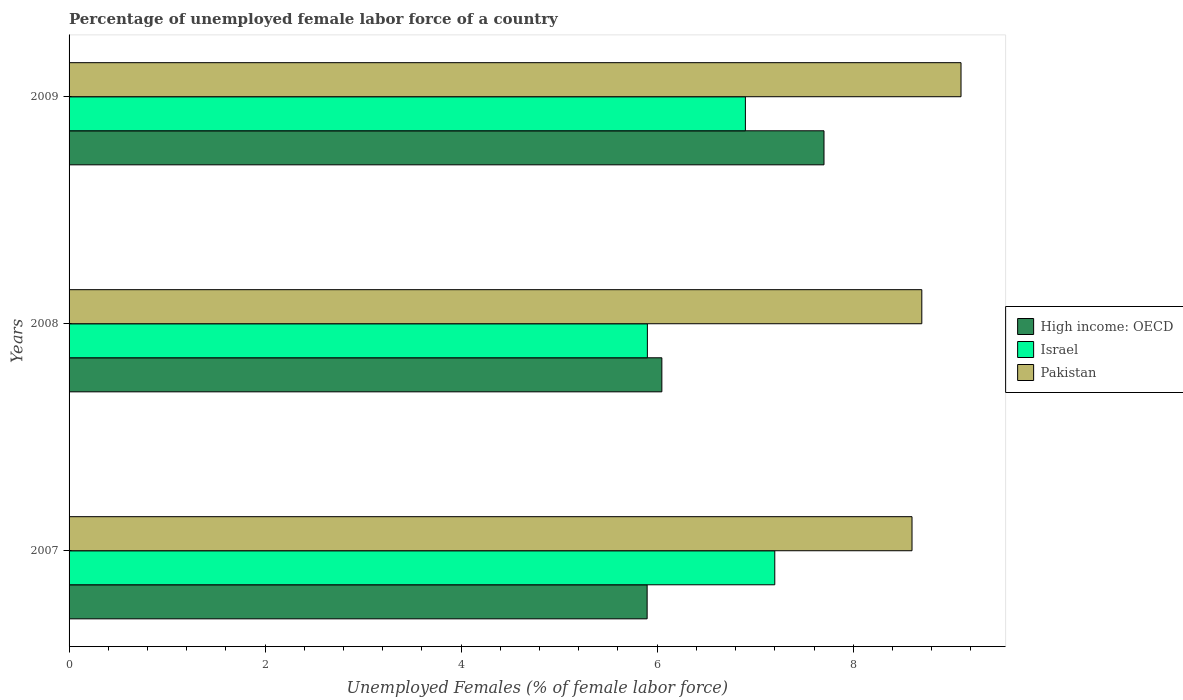How many different coloured bars are there?
Provide a short and direct response. 3. In how many cases, is the number of bars for a given year not equal to the number of legend labels?
Give a very brief answer. 0. What is the percentage of unemployed female labor force in High income: OECD in 2009?
Offer a terse response. 7.7. Across all years, what is the maximum percentage of unemployed female labor force in Pakistan?
Make the answer very short. 9.1. Across all years, what is the minimum percentage of unemployed female labor force in High income: OECD?
Provide a succinct answer. 5.9. In which year was the percentage of unemployed female labor force in Pakistan minimum?
Your answer should be very brief. 2007. What is the total percentage of unemployed female labor force in High income: OECD in the graph?
Your answer should be very brief. 19.65. What is the difference between the percentage of unemployed female labor force in High income: OECD in 2008 and that in 2009?
Provide a succinct answer. -1.65. What is the difference between the percentage of unemployed female labor force in Israel in 2008 and the percentage of unemployed female labor force in Pakistan in 2007?
Provide a short and direct response. -2.7. What is the average percentage of unemployed female labor force in High income: OECD per year?
Offer a terse response. 6.55. In the year 2009, what is the difference between the percentage of unemployed female labor force in Israel and percentage of unemployed female labor force in High income: OECD?
Make the answer very short. -0.8. What is the ratio of the percentage of unemployed female labor force in Pakistan in 2008 to that in 2009?
Keep it short and to the point. 0.96. Is the difference between the percentage of unemployed female labor force in Israel in 2007 and 2008 greater than the difference between the percentage of unemployed female labor force in High income: OECD in 2007 and 2008?
Give a very brief answer. Yes. What is the difference between the highest and the second highest percentage of unemployed female labor force in Israel?
Provide a short and direct response. 0.3. What is the difference between the highest and the lowest percentage of unemployed female labor force in High income: OECD?
Your response must be concise. 1.8. In how many years, is the percentage of unemployed female labor force in High income: OECD greater than the average percentage of unemployed female labor force in High income: OECD taken over all years?
Provide a short and direct response. 1. Is it the case that in every year, the sum of the percentage of unemployed female labor force in Israel and percentage of unemployed female labor force in High income: OECD is greater than the percentage of unemployed female labor force in Pakistan?
Provide a succinct answer. Yes. Are all the bars in the graph horizontal?
Your response must be concise. Yes. How many years are there in the graph?
Provide a short and direct response. 3. What is the difference between two consecutive major ticks on the X-axis?
Offer a terse response. 2. How are the legend labels stacked?
Ensure brevity in your answer.  Vertical. What is the title of the graph?
Ensure brevity in your answer.  Percentage of unemployed female labor force of a country. Does "St. Vincent and the Grenadines" appear as one of the legend labels in the graph?
Offer a terse response. No. What is the label or title of the X-axis?
Make the answer very short. Unemployed Females (% of female labor force). What is the Unemployed Females (% of female labor force) in High income: OECD in 2007?
Your answer should be compact. 5.9. What is the Unemployed Females (% of female labor force) in Israel in 2007?
Make the answer very short. 7.2. What is the Unemployed Females (% of female labor force) of Pakistan in 2007?
Offer a very short reply. 8.6. What is the Unemployed Females (% of female labor force) of High income: OECD in 2008?
Your response must be concise. 6.05. What is the Unemployed Females (% of female labor force) in Israel in 2008?
Give a very brief answer. 5.9. What is the Unemployed Females (% of female labor force) in Pakistan in 2008?
Your answer should be very brief. 8.7. What is the Unemployed Females (% of female labor force) in High income: OECD in 2009?
Your response must be concise. 7.7. What is the Unemployed Females (% of female labor force) of Israel in 2009?
Provide a short and direct response. 6.9. What is the Unemployed Females (% of female labor force) in Pakistan in 2009?
Make the answer very short. 9.1. Across all years, what is the maximum Unemployed Females (% of female labor force) of High income: OECD?
Offer a terse response. 7.7. Across all years, what is the maximum Unemployed Females (% of female labor force) of Israel?
Provide a short and direct response. 7.2. Across all years, what is the maximum Unemployed Females (% of female labor force) in Pakistan?
Give a very brief answer. 9.1. Across all years, what is the minimum Unemployed Females (% of female labor force) of High income: OECD?
Ensure brevity in your answer.  5.9. Across all years, what is the minimum Unemployed Females (% of female labor force) of Israel?
Your answer should be very brief. 5.9. Across all years, what is the minimum Unemployed Females (% of female labor force) in Pakistan?
Your answer should be very brief. 8.6. What is the total Unemployed Females (% of female labor force) in High income: OECD in the graph?
Offer a terse response. 19.65. What is the total Unemployed Females (% of female labor force) of Israel in the graph?
Keep it short and to the point. 20. What is the total Unemployed Females (% of female labor force) in Pakistan in the graph?
Your response must be concise. 26.4. What is the difference between the Unemployed Females (% of female labor force) in High income: OECD in 2007 and that in 2008?
Offer a terse response. -0.15. What is the difference between the Unemployed Females (% of female labor force) of Israel in 2007 and that in 2008?
Your answer should be compact. 1.3. What is the difference between the Unemployed Females (% of female labor force) of High income: OECD in 2007 and that in 2009?
Offer a terse response. -1.8. What is the difference between the Unemployed Females (% of female labor force) of Israel in 2007 and that in 2009?
Your answer should be very brief. 0.3. What is the difference between the Unemployed Females (% of female labor force) in Pakistan in 2007 and that in 2009?
Give a very brief answer. -0.5. What is the difference between the Unemployed Females (% of female labor force) in High income: OECD in 2008 and that in 2009?
Your answer should be compact. -1.65. What is the difference between the Unemployed Females (% of female labor force) of Israel in 2008 and that in 2009?
Offer a terse response. -1. What is the difference between the Unemployed Females (% of female labor force) in Pakistan in 2008 and that in 2009?
Provide a short and direct response. -0.4. What is the difference between the Unemployed Females (% of female labor force) in High income: OECD in 2007 and the Unemployed Females (% of female labor force) in Israel in 2008?
Ensure brevity in your answer.  -0. What is the difference between the Unemployed Females (% of female labor force) in High income: OECD in 2007 and the Unemployed Females (% of female labor force) in Pakistan in 2008?
Offer a terse response. -2.8. What is the difference between the Unemployed Females (% of female labor force) in Israel in 2007 and the Unemployed Females (% of female labor force) in Pakistan in 2008?
Offer a very short reply. -1.5. What is the difference between the Unemployed Females (% of female labor force) of High income: OECD in 2007 and the Unemployed Females (% of female labor force) of Israel in 2009?
Keep it short and to the point. -1. What is the difference between the Unemployed Females (% of female labor force) in High income: OECD in 2007 and the Unemployed Females (% of female labor force) in Pakistan in 2009?
Your answer should be very brief. -3.2. What is the difference between the Unemployed Females (% of female labor force) of High income: OECD in 2008 and the Unemployed Females (% of female labor force) of Israel in 2009?
Provide a succinct answer. -0.85. What is the difference between the Unemployed Females (% of female labor force) in High income: OECD in 2008 and the Unemployed Females (% of female labor force) in Pakistan in 2009?
Offer a very short reply. -3.05. What is the average Unemployed Females (% of female labor force) of High income: OECD per year?
Offer a very short reply. 6.55. In the year 2007, what is the difference between the Unemployed Females (% of female labor force) in High income: OECD and Unemployed Females (% of female labor force) in Israel?
Provide a succinct answer. -1.3. In the year 2007, what is the difference between the Unemployed Females (% of female labor force) in High income: OECD and Unemployed Females (% of female labor force) in Pakistan?
Provide a succinct answer. -2.7. In the year 2007, what is the difference between the Unemployed Females (% of female labor force) in Israel and Unemployed Females (% of female labor force) in Pakistan?
Offer a very short reply. -1.4. In the year 2008, what is the difference between the Unemployed Females (% of female labor force) of High income: OECD and Unemployed Females (% of female labor force) of Israel?
Your answer should be compact. 0.15. In the year 2008, what is the difference between the Unemployed Females (% of female labor force) of High income: OECD and Unemployed Females (% of female labor force) of Pakistan?
Keep it short and to the point. -2.65. In the year 2009, what is the difference between the Unemployed Females (% of female labor force) in High income: OECD and Unemployed Females (% of female labor force) in Israel?
Keep it short and to the point. 0.8. In the year 2009, what is the difference between the Unemployed Females (% of female labor force) of High income: OECD and Unemployed Females (% of female labor force) of Pakistan?
Keep it short and to the point. -1.4. What is the ratio of the Unemployed Females (% of female labor force) in High income: OECD in 2007 to that in 2008?
Your answer should be compact. 0.98. What is the ratio of the Unemployed Females (% of female labor force) in Israel in 2007 to that in 2008?
Offer a very short reply. 1.22. What is the ratio of the Unemployed Females (% of female labor force) of High income: OECD in 2007 to that in 2009?
Provide a succinct answer. 0.77. What is the ratio of the Unemployed Females (% of female labor force) of Israel in 2007 to that in 2009?
Make the answer very short. 1.04. What is the ratio of the Unemployed Females (% of female labor force) in Pakistan in 2007 to that in 2009?
Offer a terse response. 0.95. What is the ratio of the Unemployed Females (% of female labor force) in High income: OECD in 2008 to that in 2009?
Provide a short and direct response. 0.79. What is the ratio of the Unemployed Females (% of female labor force) of Israel in 2008 to that in 2009?
Ensure brevity in your answer.  0.86. What is the ratio of the Unemployed Females (% of female labor force) in Pakistan in 2008 to that in 2009?
Your response must be concise. 0.96. What is the difference between the highest and the second highest Unemployed Females (% of female labor force) in High income: OECD?
Your answer should be very brief. 1.65. What is the difference between the highest and the second highest Unemployed Females (% of female labor force) of Israel?
Give a very brief answer. 0.3. What is the difference between the highest and the lowest Unemployed Females (% of female labor force) of High income: OECD?
Make the answer very short. 1.8. What is the difference between the highest and the lowest Unemployed Females (% of female labor force) in Israel?
Provide a succinct answer. 1.3. What is the difference between the highest and the lowest Unemployed Females (% of female labor force) of Pakistan?
Give a very brief answer. 0.5. 